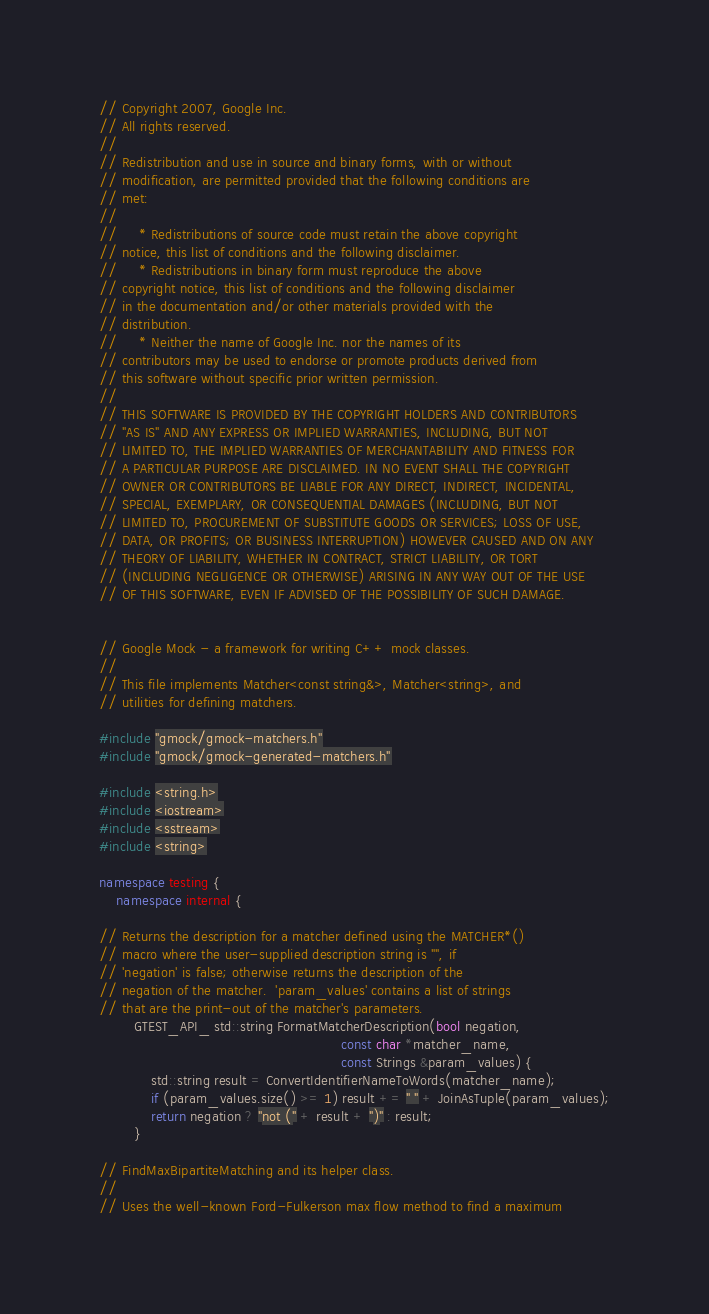<code> <loc_0><loc_0><loc_500><loc_500><_C++_>// Copyright 2007, Google Inc.
// All rights reserved.
//
// Redistribution and use in source and binary forms, with or without
// modification, are permitted provided that the following conditions are
// met:
//
//     * Redistributions of source code must retain the above copyright
// notice, this list of conditions and the following disclaimer.
//     * Redistributions in binary form must reproduce the above
// copyright notice, this list of conditions and the following disclaimer
// in the documentation and/or other materials provided with the
// distribution.
//     * Neither the name of Google Inc. nor the names of its
// contributors may be used to endorse or promote products derived from
// this software without specific prior written permission.
//
// THIS SOFTWARE IS PROVIDED BY THE COPYRIGHT HOLDERS AND CONTRIBUTORS
// "AS IS" AND ANY EXPRESS OR IMPLIED WARRANTIES, INCLUDING, BUT NOT
// LIMITED TO, THE IMPLIED WARRANTIES OF MERCHANTABILITY AND FITNESS FOR
// A PARTICULAR PURPOSE ARE DISCLAIMED. IN NO EVENT SHALL THE COPYRIGHT
// OWNER OR CONTRIBUTORS BE LIABLE FOR ANY DIRECT, INDIRECT, INCIDENTAL,
// SPECIAL, EXEMPLARY, OR CONSEQUENTIAL DAMAGES (INCLUDING, BUT NOT
// LIMITED TO, PROCUREMENT OF SUBSTITUTE GOODS OR SERVICES; LOSS OF USE,
// DATA, OR PROFITS; OR BUSINESS INTERRUPTION) HOWEVER CAUSED AND ON ANY
// THEORY OF LIABILITY, WHETHER IN CONTRACT, STRICT LIABILITY, OR TORT
// (INCLUDING NEGLIGENCE OR OTHERWISE) ARISING IN ANY WAY OUT OF THE USE
// OF THIS SOFTWARE, EVEN IF ADVISED OF THE POSSIBILITY OF SUCH DAMAGE.


// Google Mock - a framework for writing C++ mock classes.
//
// This file implements Matcher<const string&>, Matcher<string>, and
// utilities for defining matchers.

#include "gmock/gmock-matchers.h"
#include "gmock/gmock-generated-matchers.h"

#include <string.h>
#include <iostream>
#include <sstream>
#include <string>

namespace testing {
    namespace internal {

// Returns the description for a matcher defined using the MATCHER*()
// macro where the user-supplied description string is "", if
// 'negation' is false; otherwise returns the description of the
// negation of the matcher.  'param_values' contains a list of strings
// that are the print-out of the matcher's parameters.
        GTEST_API_ std::string FormatMatcherDescription(bool negation,
                                                        const char *matcher_name,
                                                        const Strings &param_values) {
            std::string result = ConvertIdentifierNameToWords(matcher_name);
            if (param_values.size() >= 1) result += " " + JoinAsTuple(param_values);
            return negation ? "not (" + result + ")" : result;
        }

// FindMaxBipartiteMatching and its helper class.
//
// Uses the well-known Ford-Fulkerson max flow method to find a maximum</code> 